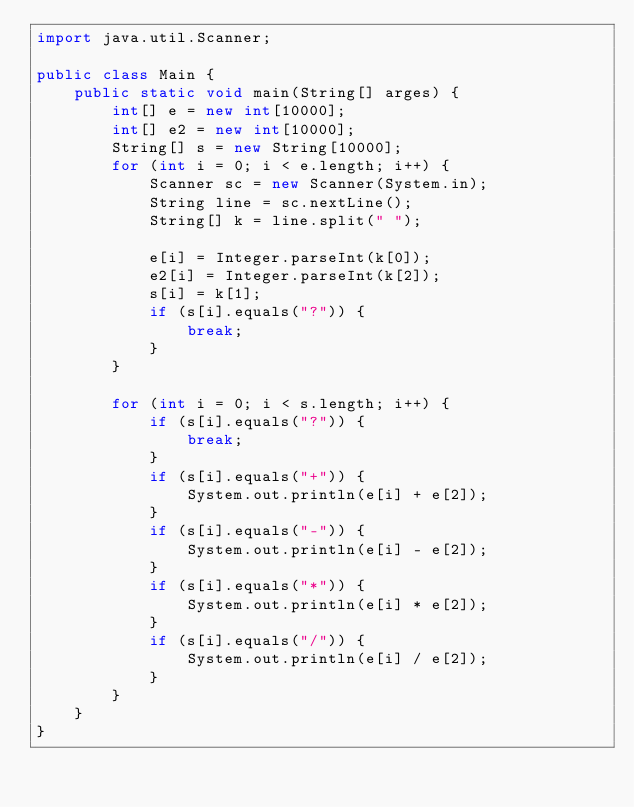<code> <loc_0><loc_0><loc_500><loc_500><_Java_>import java.util.Scanner;

public class Main {
	public static void main(String[] arges) {
		int[] e = new int[10000];
		int[] e2 = new int[10000];
		String[] s = new String[10000];
		for (int i = 0; i < e.length; i++) {
			Scanner sc = new Scanner(System.in);
			String line = sc.nextLine();
			String[] k = line.split(" ");

			e[i] = Integer.parseInt(k[0]);
			e2[i] = Integer.parseInt(k[2]);
			s[i] = k[1];
			if (s[i].equals("?")) {
				break;
			}
		}

		for (int i = 0; i < s.length; i++) {
			if (s[i].equals("?")) {
				break;
			}
			if (s[i].equals("+")) {
				System.out.println(e[i] + e[2]);
			}
			if (s[i].equals("-")) {
				System.out.println(e[i] - e[2]);
			}
			if (s[i].equals("*")) {
				System.out.println(e[i] * e[2]);
			}
			if (s[i].equals("/")) {
				System.out.println(e[i] / e[2]);
			}
		}
	}
}</code> 